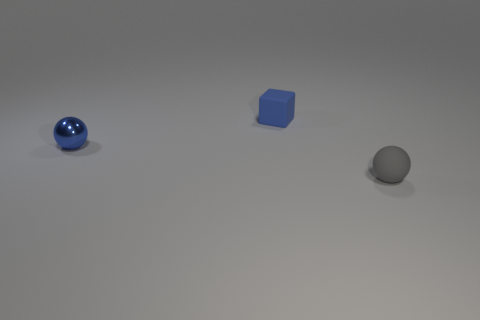Add 2 small shiny balls. How many objects exist? 5 Subtract all balls. How many objects are left? 1 Subtract 0 cyan cubes. How many objects are left? 3 Subtract all small green cubes. Subtract all tiny rubber things. How many objects are left? 1 Add 2 small metal things. How many small metal things are left? 3 Add 1 blue metal balls. How many blue metal balls exist? 2 